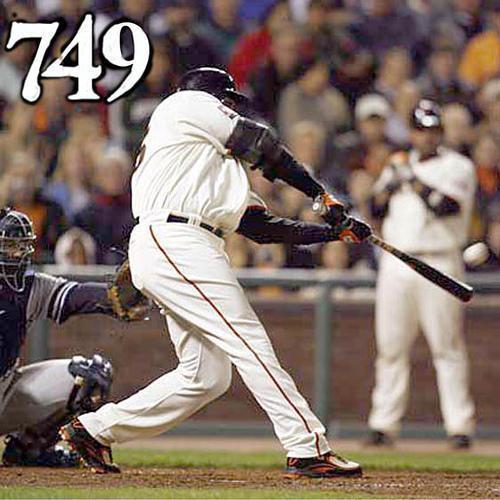How many people are there?
Give a very brief answer. 4. How many people have remotes in their hands?
Give a very brief answer. 0. 